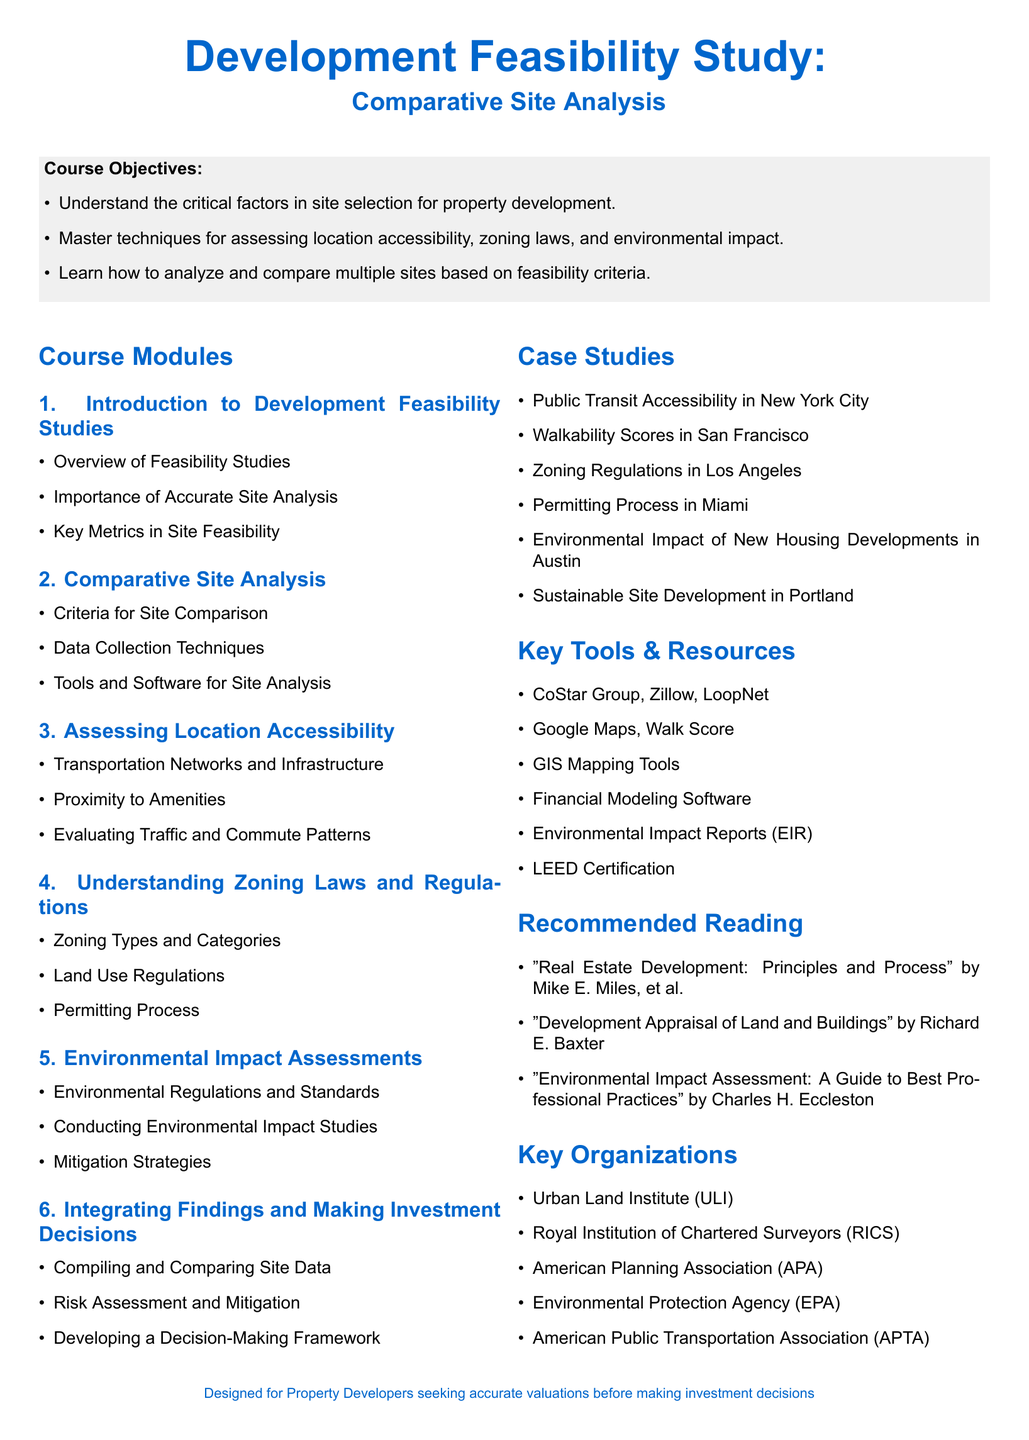What is the main title of the document? The main title is indicated at the center of the document, highlighting the subject matter of the syllabus.
Answer: Development Feasibility Study: Comparative Site Analysis How many modules are included in the course? The document lists several modules under the course structure; counting these provides the answer.
Answer: Six Name one case study mentioned in the syllabus. The document lists various case studies in a bullet point format under the case studies section.
Answer: Public Transit Accessibility in New York City What type of organizations are listed in the syllabus? The document specifies key organizations related to property development, indicating their relevance to the course.
Answer: Key Organizations What is the purpose of the course as stated in the course objectives? The objectives describe the main learning goals for participants in the course.
Answer: Understand the critical factors in site selection for property development Which software or tools are recommended for site analysis? The syllabus outlines a list of key tools and resources that are beneficial for conducting site analysis.
Answer: CoStar Group, Zillow, LoopNet What is the focus of module three in the syllabus? This module discusses specific aspects related to the accessibility of locations, as mentioned in the module's title.
Answer: Assessing Location Accessibility What is one of the recommended readings listed in the syllabus? The document includes a list of recommended readings, which provide further insight into real estate development topics.
Answer: "Real Estate Development: Principles and Process" by Mike E. Miles, et al 